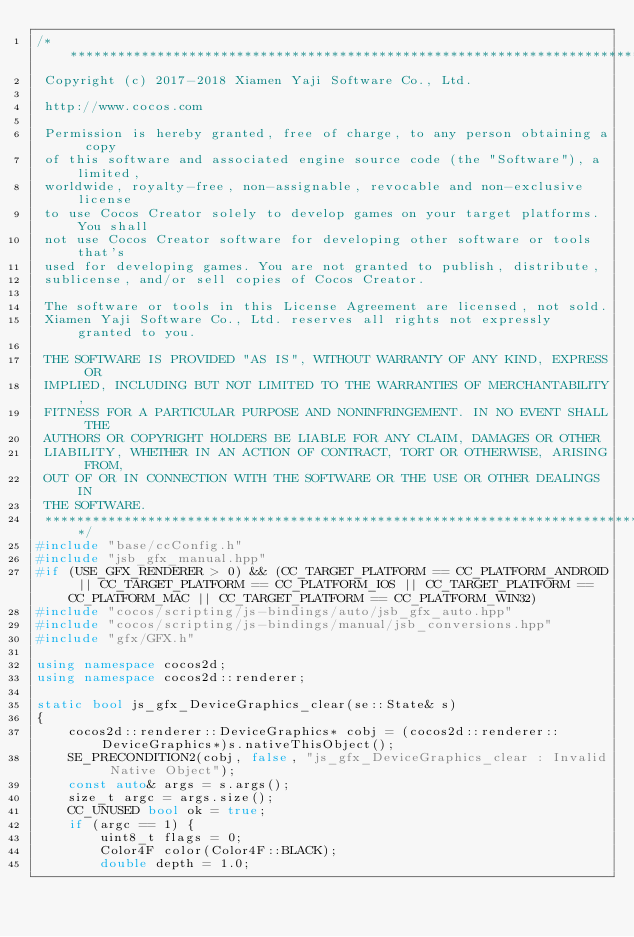Convert code to text. <code><loc_0><loc_0><loc_500><loc_500><_C++_>/****************************************************************************
 Copyright (c) 2017-2018 Xiamen Yaji Software Co., Ltd.

 http://www.cocos.com

 Permission is hereby granted, free of charge, to any person obtaining a copy
 of this software and associated engine source code (the "Software"), a limited,
 worldwide, royalty-free, non-assignable, revocable and non-exclusive license
 to use Cocos Creator solely to develop games on your target platforms. You shall
 not use Cocos Creator software for developing other software or tools that's
 used for developing games. You are not granted to publish, distribute,
 sublicense, and/or sell copies of Cocos Creator.

 The software or tools in this License Agreement are licensed, not sold.
 Xiamen Yaji Software Co., Ltd. reserves all rights not expressly granted to you.

 THE SOFTWARE IS PROVIDED "AS IS", WITHOUT WARRANTY OF ANY KIND, EXPRESS OR
 IMPLIED, INCLUDING BUT NOT LIMITED TO THE WARRANTIES OF MERCHANTABILITY,
 FITNESS FOR A PARTICULAR PURPOSE AND NONINFRINGEMENT. IN NO EVENT SHALL THE
 AUTHORS OR COPYRIGHT HOLDERS BE LIABLE FOR ANY CLAIM, DAMAGES OR OTHER
 LIABILITY, WHETHER IN AN ACTION OF CONTRACT, TORT OR OTHERWISE, ARISING FROM,
 OUT OF OR IN CONNECTION WITH THE SOFTWARE OR THE USE OR OTHER DEALINGS IN
 THE SOFTWARE.
 ****************************************************************************/
#include "base/ccConfig.h"
#include "jsb_gfx_manual.hpp"
#if (USE_GFX_RENDERER > 0) && (CC_TARGET_PLATFORM == CC_PLATFORM_ANDROID || CC_TARGET_PLATFORM == CC_PLATFORM_IOS || CC_TARGET_PLATFORM == CC_PLATFORM_MAC || CC_TARGET_PLATFORM == CC_PLATFORM_WIN32)
#include "cocos/scripting/js-bindings/auto/jsb_gfx_auto.hpp"
#include "cocos/scripting/js-bindings/manual/jsb_conversions.hpp"
#include "gfx/GFX.h"

using namespace cocos2d;
using namespace cocos2d::renderer;

static bool js_gfx_DeviceGraphics_clear(se::State& s)
{
    cocos2d::renderer::DeviceGraphics* cobj = (cocos2d::renderer::DeviceGraphics*)s.nativeThisObject();
    SE_PRECONDITION2(cobj, false, "js_gfx_DeviceGraphics_clear : Invalid Native Object");
    const auto& args = s.args();
    size_t argc = args.size();
    CC_UNUSED bool ok = true;
    if (argc == 1) {
        uint8_t flags = 0;
        Color4F color(Color4F::BLACK);
        double depth = 1.0;</code> 